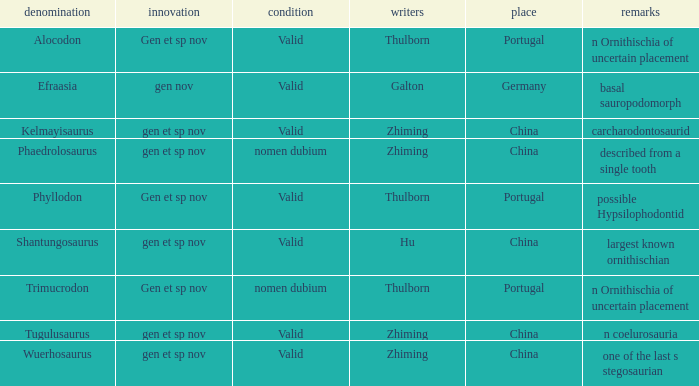What is the Name of the dinosaur that was discovered in the Location, China, and whose Notes are, "described from a single tooth"? Phaedrolosaurus. 